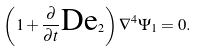Convert formula to latex. <formula><loc_0><loc_0><loc_500><loc_500>\left ( 1 + \frac { \partial } { \partial t } \text {De} _ { 2 } \right ) \nabla ^ { 4 } \Psi _ { 1 } = 0 .</formula> 